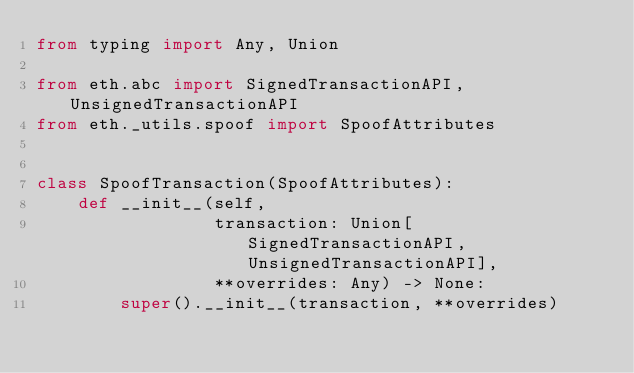Convert code to text. <code><loc_0><loc_0><loc_500><loc_500><_Python_>from typing import Any, Union

from eth.abc import SignedTransactionAPI, UnsignedTransactionAPI
from eth._utils.spoof import SpoofAttributes


class SpoofTransaction(SpoofAttributes):
    def __init__(self,
                 transaction: Union[SignedTransactionAPI, UnsignedTransactionAPI],
                 **overrides: Any) -> None:
        super().__init__(transaction, **overrides)
</code> 